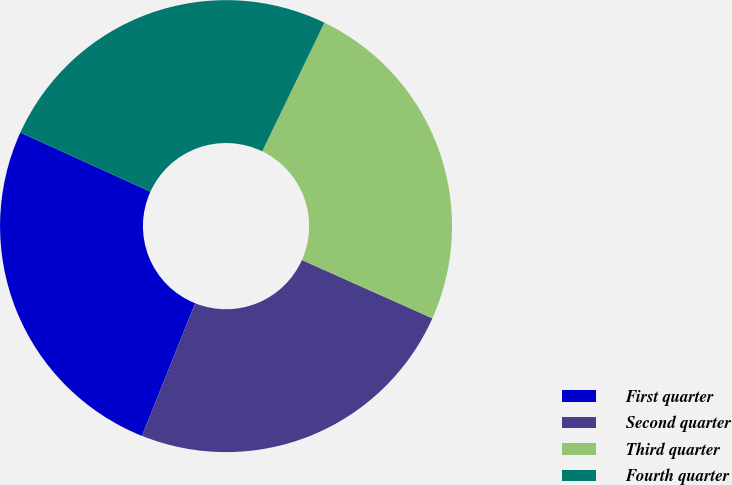Convert chart to OTSL. <chart><loc_0><loc_0><loc_500><loc_500><pie_chart><fcel>First quarter<fcel>Second quarter<fcel>Third quarter<fcel>Fourth quarter<nl><fcel>25.73%<fcel>24.38%<fcel>24.52%<fcel>25.37%<nl></chart> 